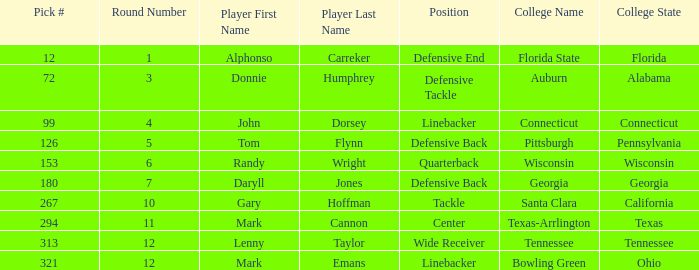Who is a wide receiver player? Lenny Taylor. 